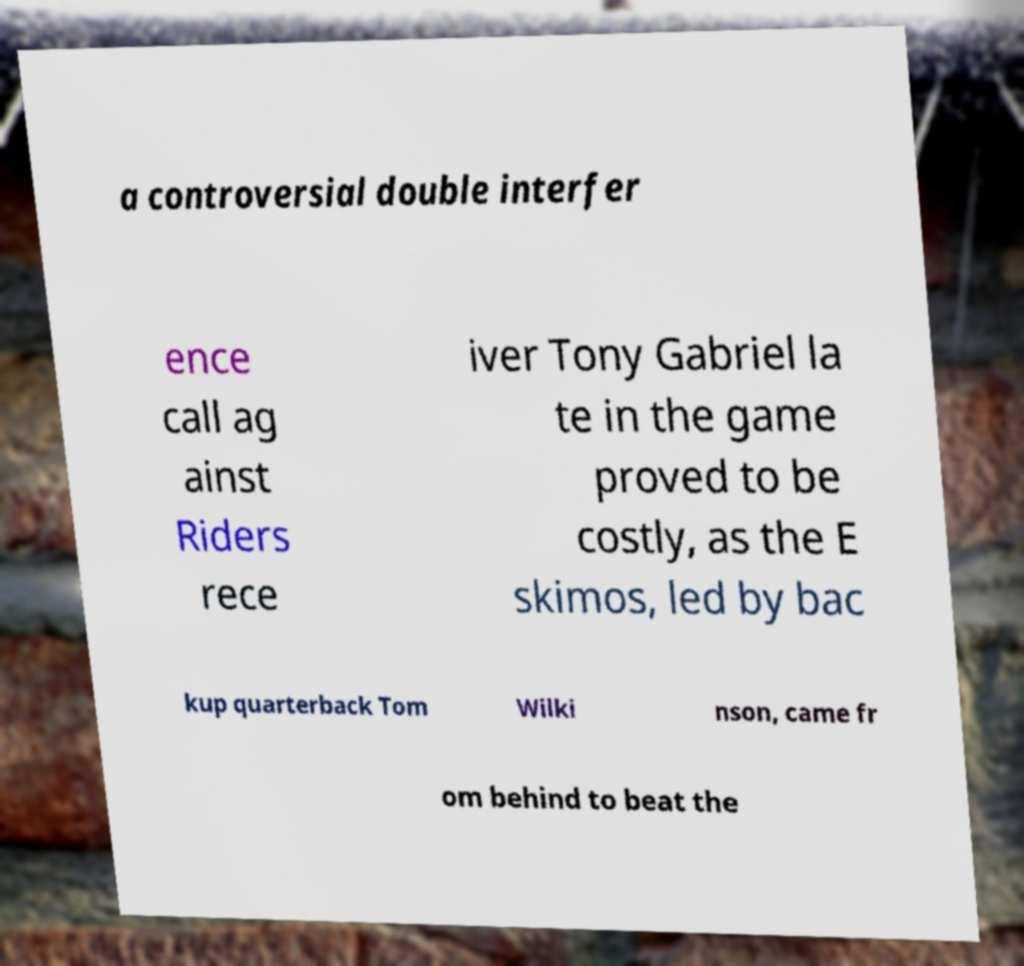Could you extract and type out the text from this image? a controversial double interfer ence call ag ainst Riders rece iver Tony Gabriel la te in the game proved to be costly, as the E skimos, led by bac kup quarterback Tom Wilki nson, came fr om behind to beat the 